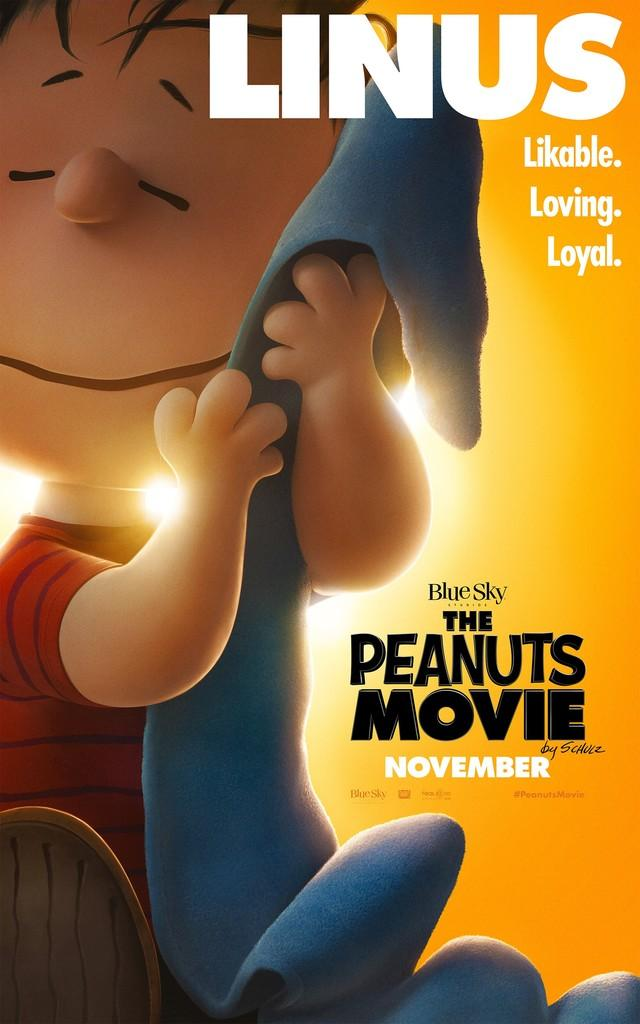What is the main subject of the image? The main subject of the image is an animated boy. What is the boy doing in the image? The boy is holding an object in the image. Is there any text present in the image? Yes, there is text written on the image. How many frogs are sitting on the eggnog in the image? There are no frogs or eggnog present in the image. 